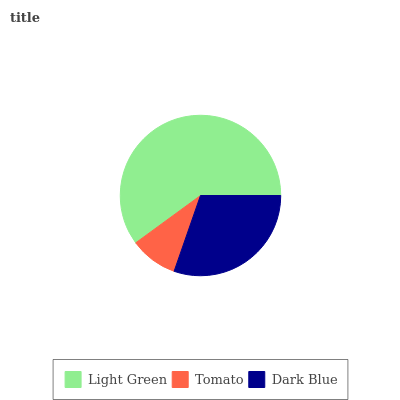Is Tomato the minimum?
Answer yes or no. Yes. Is Light Green the maximum?
Answer yes or no. Yes. Is Dark Blue the minimum?
Answer yes or no. No. Is Dark Blue the maximum?
Answer yes or no. No. Is Dark Blue greater than Tomato?
Answer yes or no. Yes. Is Tomato less than Dark Blue?
Answer yes or no. Yes. Is Tomato greater than Dark Blue?
Answer yes or no. No. Is Dark Blue less than Tomato?
Answer yes or no. No. Is Dark Blue the high median?
Answer yes or no. Yes. Is Dark Blue the low median?
Answer yes or no. Yes. Is Light Green the high median?
Answer yes or no. No. Is Tomato the low median?
Answer yes or no. No. 